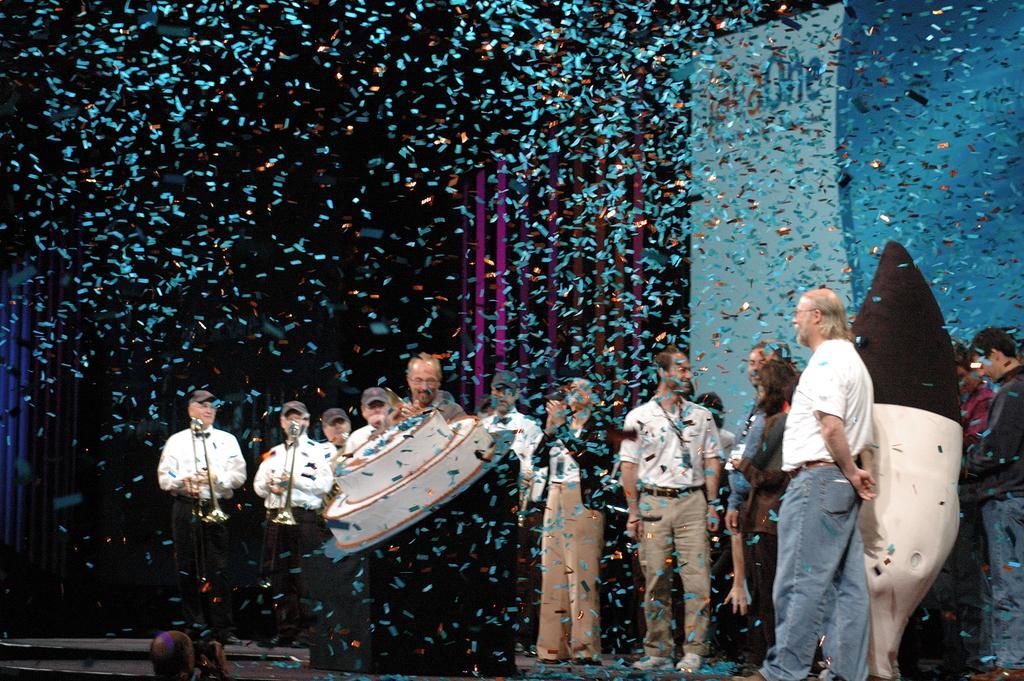Could you give a brief overview of what you see in this image? In this picture we can see a group of people, here we can see musical instruments and some objects. 